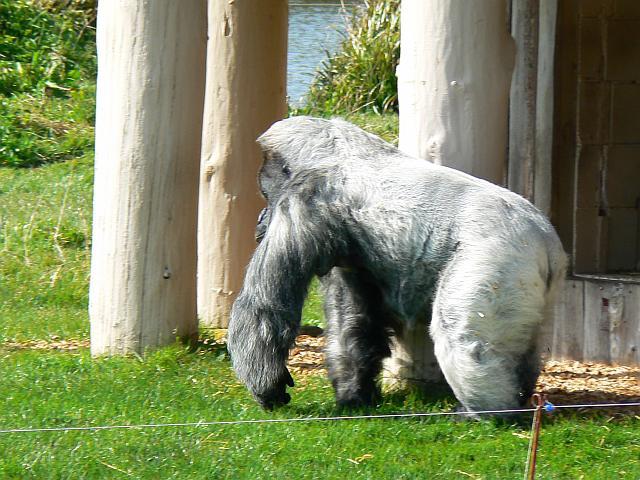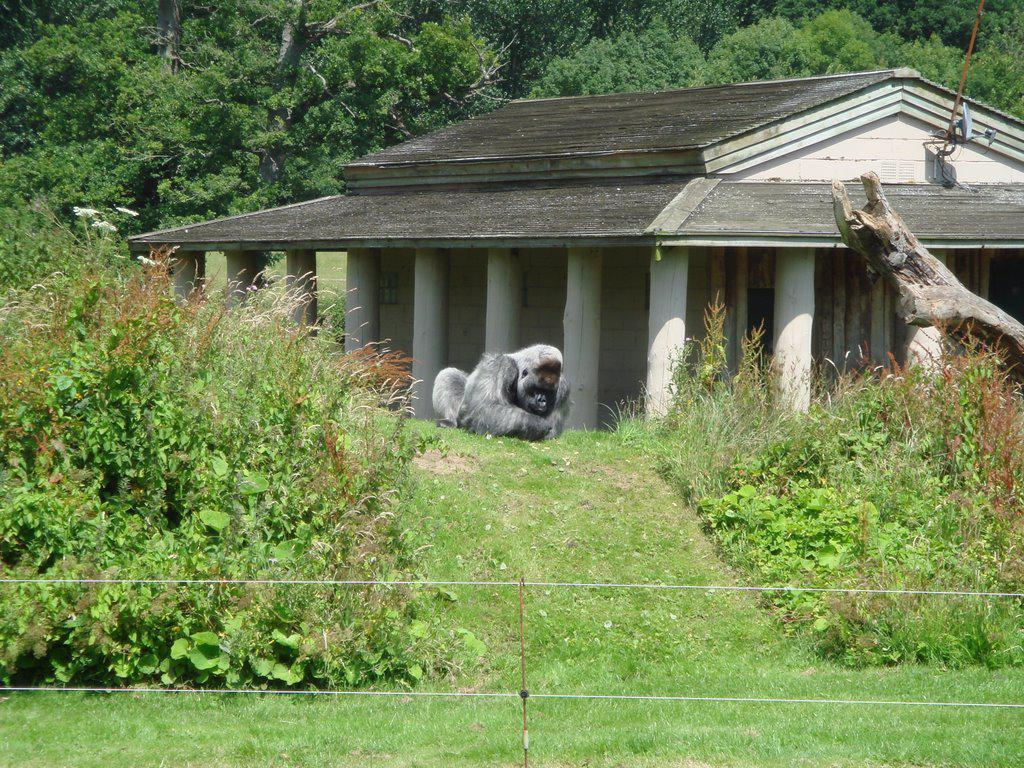The first image is the image on the left, the second image is the image on the right. Assess this claim about the two images: "The gorilla in the right image is sitting in the grass near a bunch of weeds.". Correct or not? Answer yes or no. Yes. The first image is the image on the left, the second image is the image on the right. Given the left and right images, does the statement "One image includes a silverback gorilla on all fours, and the other shows a silverback gorilla sitting on green grass." hold true? Answer yes or no. Yes. 